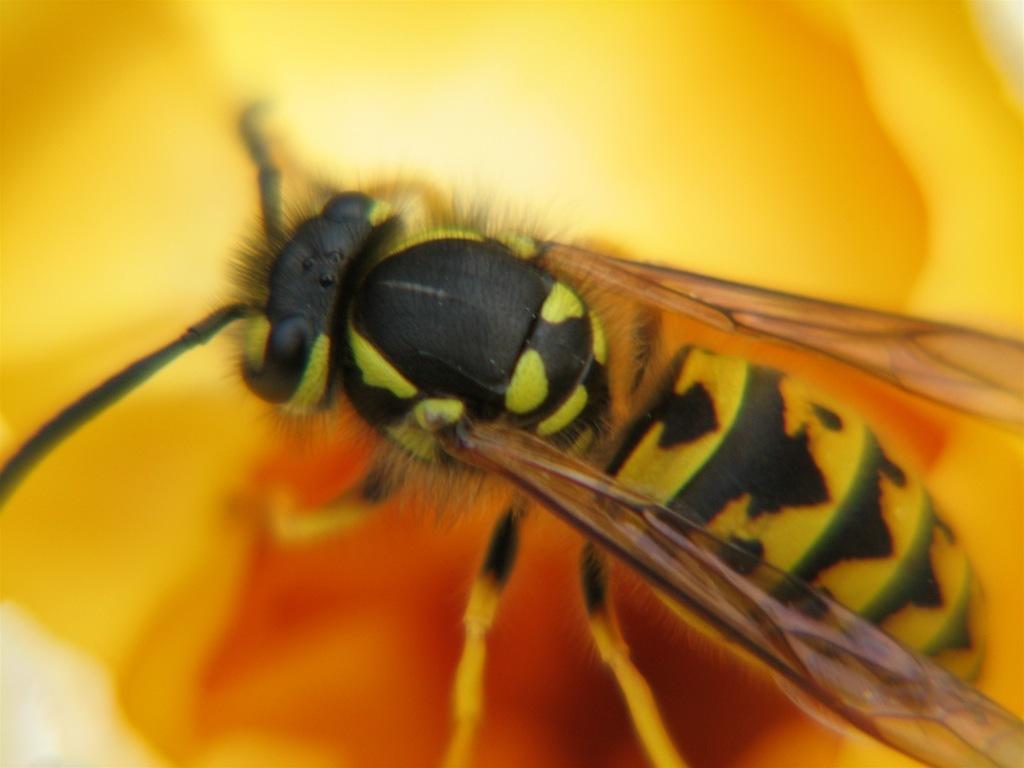Please provide a concise description of this image. In this image we can see a fly. 